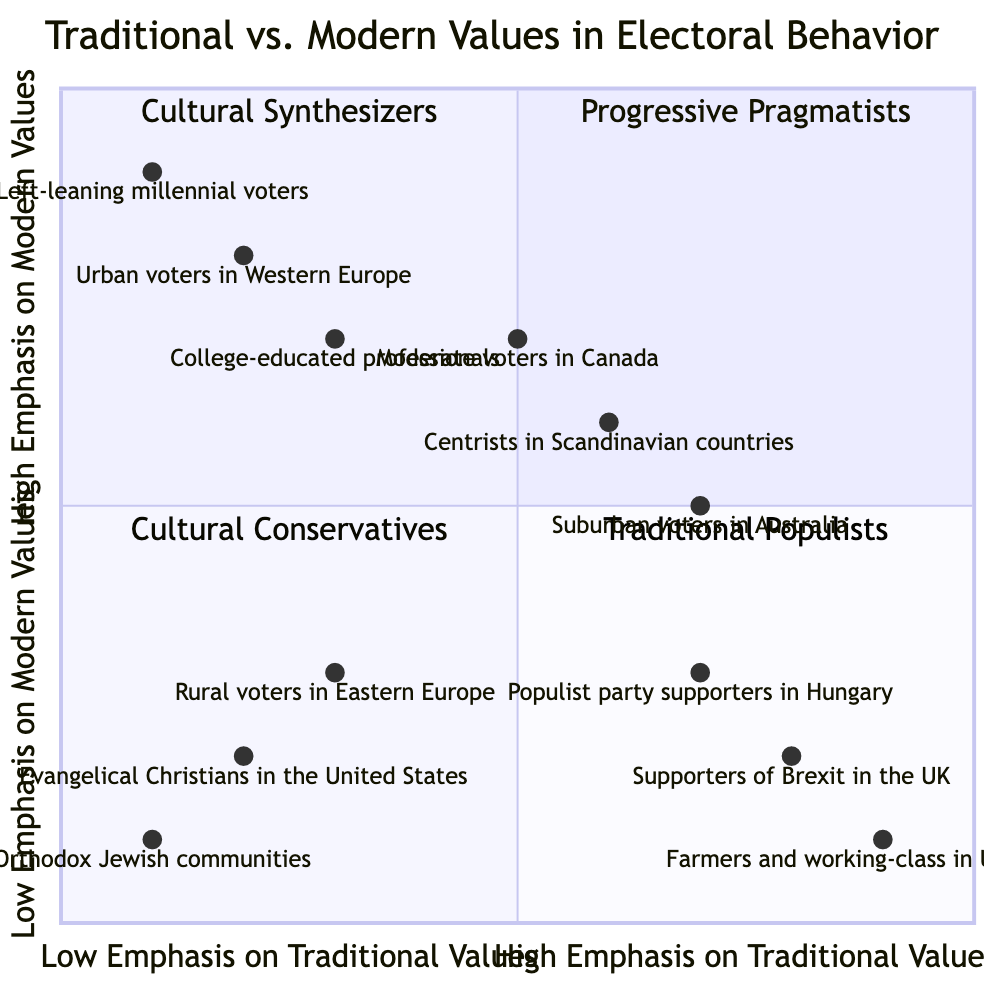What do we call voters who prioritize traditional values and are skeptical of modern values? In the quadrant chart, the voters in the bottom left quadrant represent those who have low emphasis on both traditional and modern values. They are described as "Cultural Conservatives."
Answer: Cultural Conservatives Which quadrant includes urban voters in Western Europe? The urban voters in Western Europe are located within the second quadrant (top left), which is identified as "Progressive Pragmatists."
Answer: Progressive Pragmatists How many examples are provided for Cultural Synthesizers? The diagram lists three specific groups as examples for Cultural Synthesizers: Centrists in Scandinavian countries, Moderate voters in Canada, and Suburban voters in Australia. So, there are three examples given.
Answer: 3 What is the description of Traditional Populists? In the quadrant labeled "Traditional Populists," the description is that these voters place a strong emphasis on traditional values and resist rapid social change.
Answer: Strong emphasis on traditional values Which group is located at coordinates [0.5, 0.7]? The coordinates [0.5, 0.7] correspond to "Moderate voters in Canada," which fall in the quadrant for Cultural Synthesizers.
Answer: Moderate voters in Canada What type of voters are found in the bottom right quadrant? The bottom right quadrant is labeled "Traditional Populists," indicating the type of voters found there strongly focus on traditional values and are resistant to modern changes.
Answer: Traditional Populists Which quadrant contains the fewest nodes? The quadrant that contains the fewest nodes is the third quadrant, which is labeled "Cultural Conservatives," since it has only three specific examples listed.
Answer: Cultural Conservatives What is the emphasis level for Traditional Populists on modern values? Traditional Populists have a low emphasis on modern values as indicated by their positioning in the bottom right quadrant.
Answer: Low Emphasis on Modern Values Which quadrant has a mix of respect for traditional values and acceptance of modern changes? The quadrant that reflects a balance between respect for traditional values and acceptance of modern changes is labeled "Cultural Synthesizers."
Answer: Cultural Synthesizers 